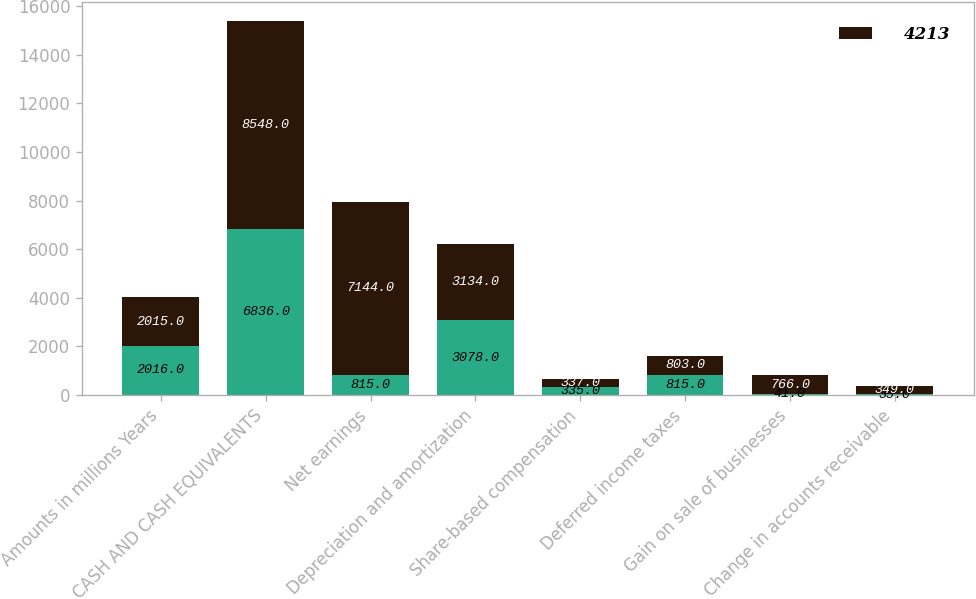<chart> <loc_0><loc_0><loc_500><loc_500><stacked_bar_chart><ecel><fcel>Amounts in millions Years<fcel>CASH AND CASH EQUIVALENTS<fcel>Net earnings<fcel>Depreciation and amortization<fcel>Share-based compensation<fcel>Deferred income taxes<fcel>Gain on sale of businesses<fcel>Change in accounts receivable<nl><fcel>nan<fcel>2016<fcel>6836<fcel>815<fcel>3078<fcel>335<fcel>815<fcel>41<fcel>35<nl><fcel>4213<fcel>2015<fcel>8548<fcel>7144<fcel>3134<fcel>337<fcel>803<fcel>766<fcel>349<nl></chart> 